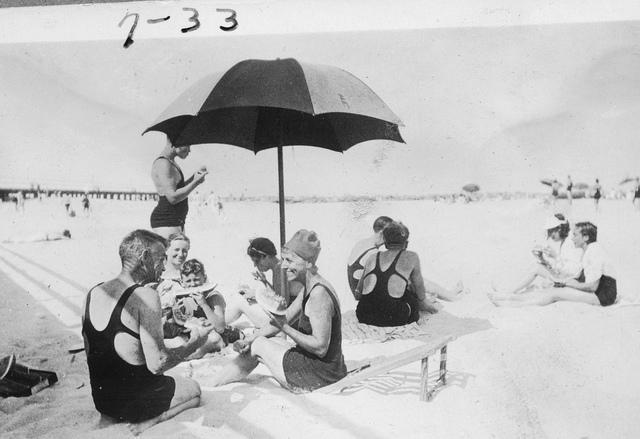How many people are visible?
Give a very brief answer. 8. How many birds are looking at the camera?
Give a very brief answer. 0. 